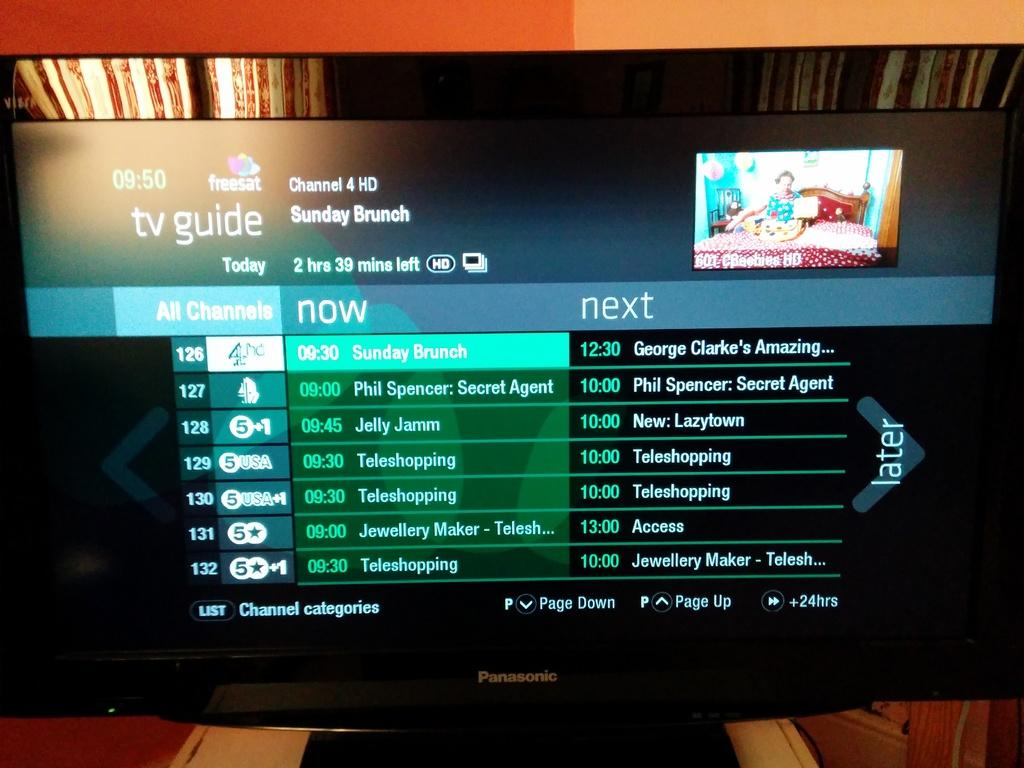<image>
Present a compact description of the photo's key features. A Panasonic tv that has the TV Guide displayed on the screen.. 